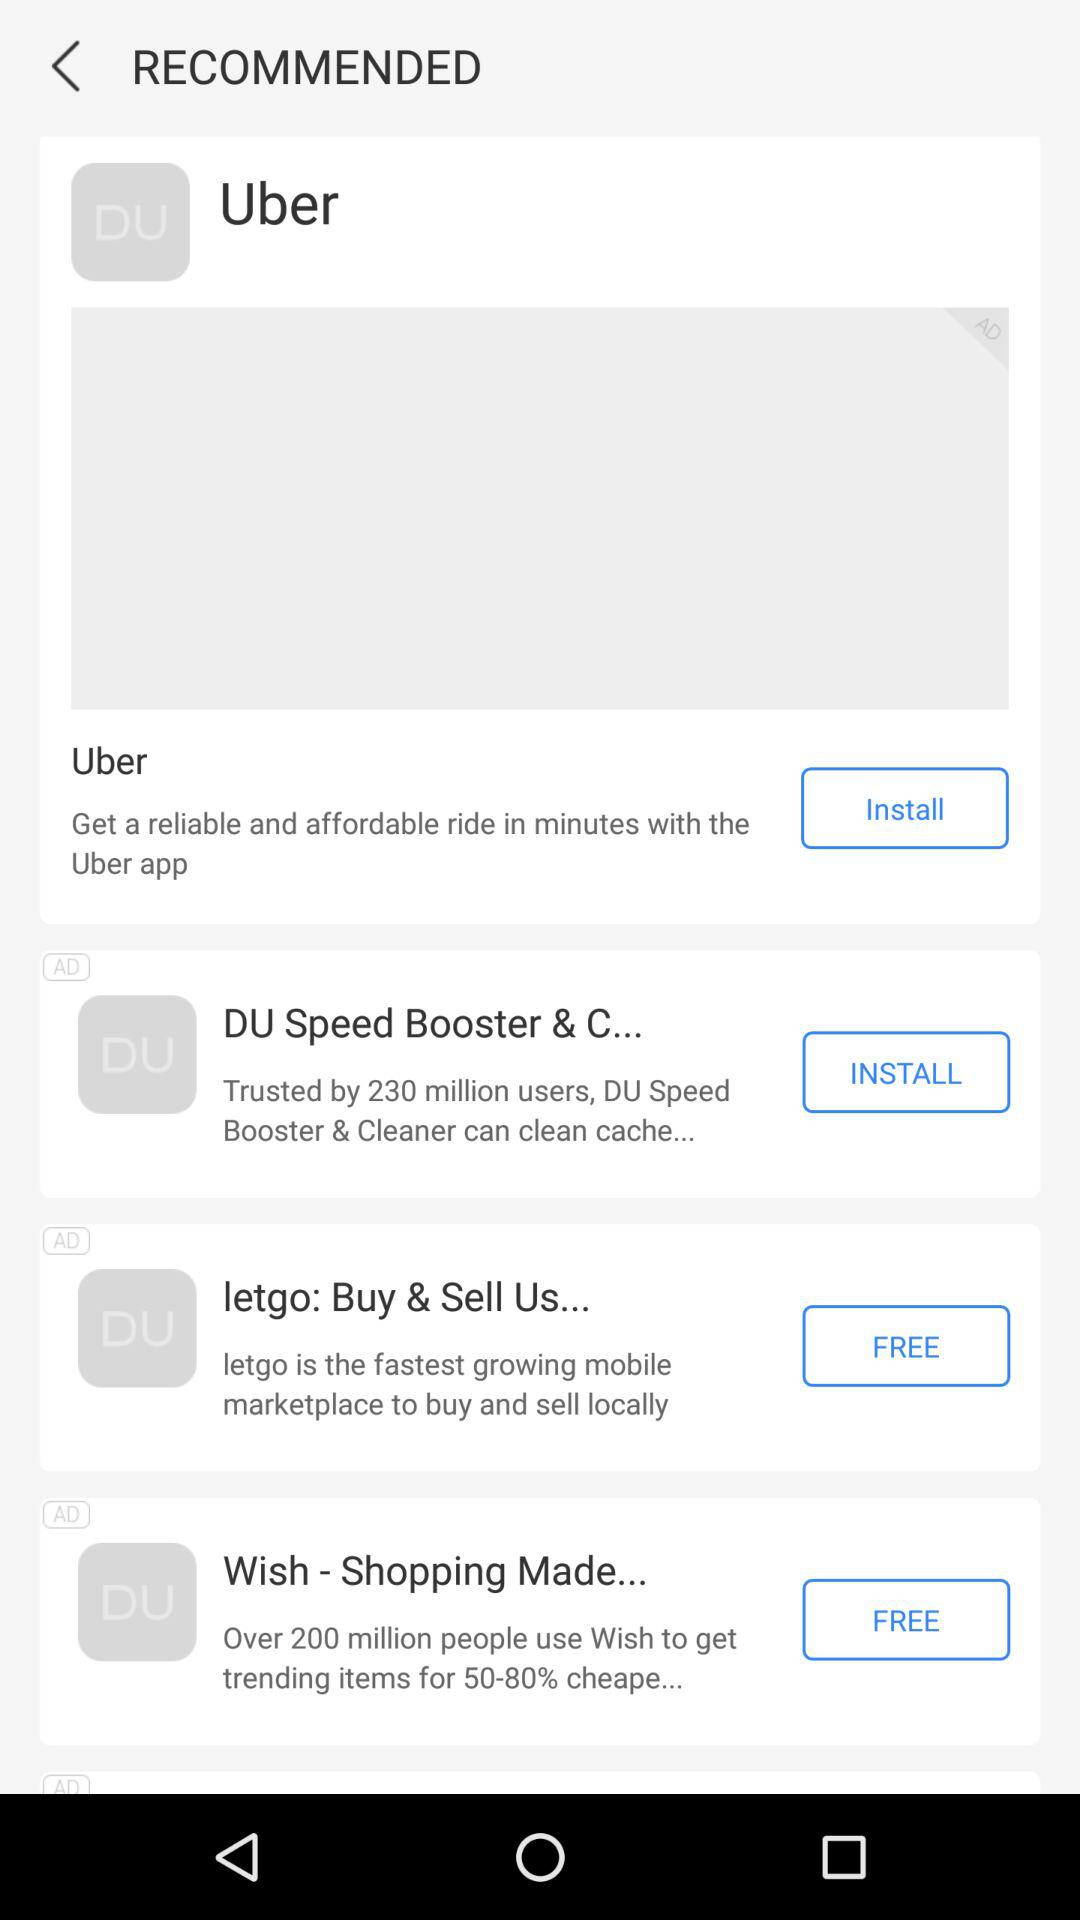How many people use the "Wish - Shopping Made..." application? There are over 200 million people using the application. 